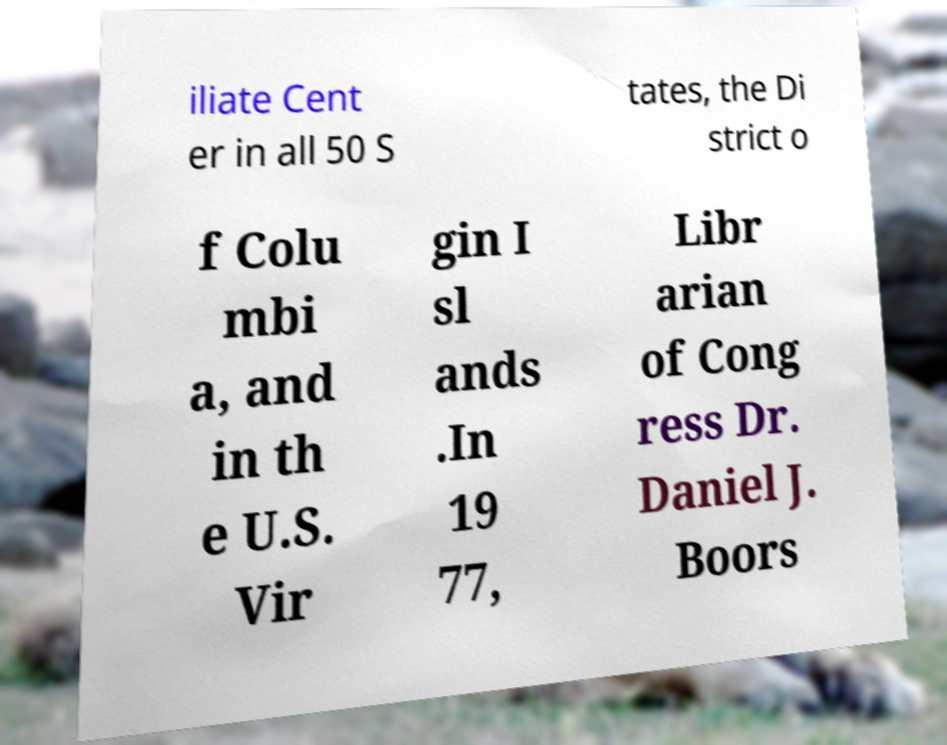For documentation purposes, I need the text within this image transcribed. Could you provide that? iliate Cent er in all 50 S tates, the Di strict o f Colu mbi a, and in th e U.S. Vir gin I sl ands .In 19 77, Libr arian of Cong ress Dr. Daniel J. Boors 